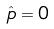<formula> <loc_0><loc_0><loc_500><loc_500>\hat { p } = 0</formula> 